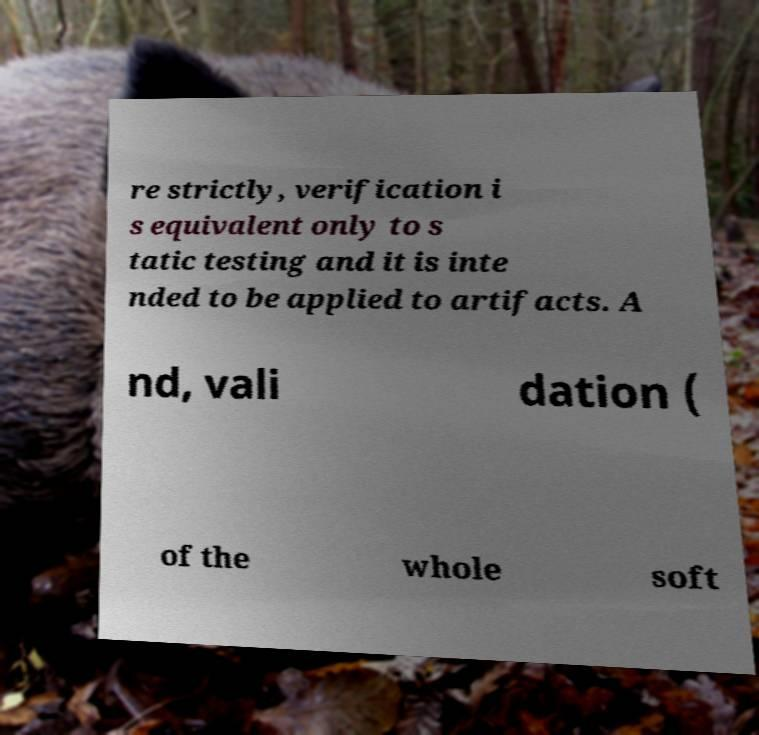There's text embedded in this image that I need extracted. Can you transcribe it verbatim? re strictly, verification i s equivalent only to s tatic testing and it is inte nded to be applied to artifacts. A nd, vali dation ( of the whole soft 